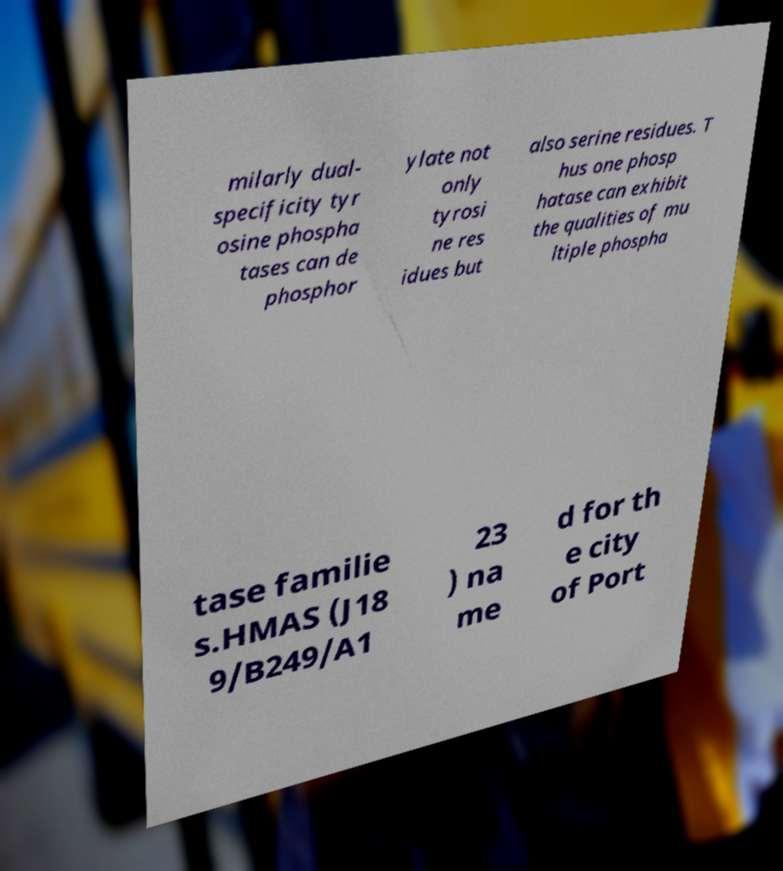Please identify and transcribe the text found in this image. milarly dual- specificity tyr osine phospha tases can de phosphor ylate not only tyrosi ne res idues but also serine residues. T hus one phosp hatase can exhibit the qualities of mu ltiple phospha tase familie s.HMAS (J18 9/B249/A1 23 ) na me d for th e city of Port 